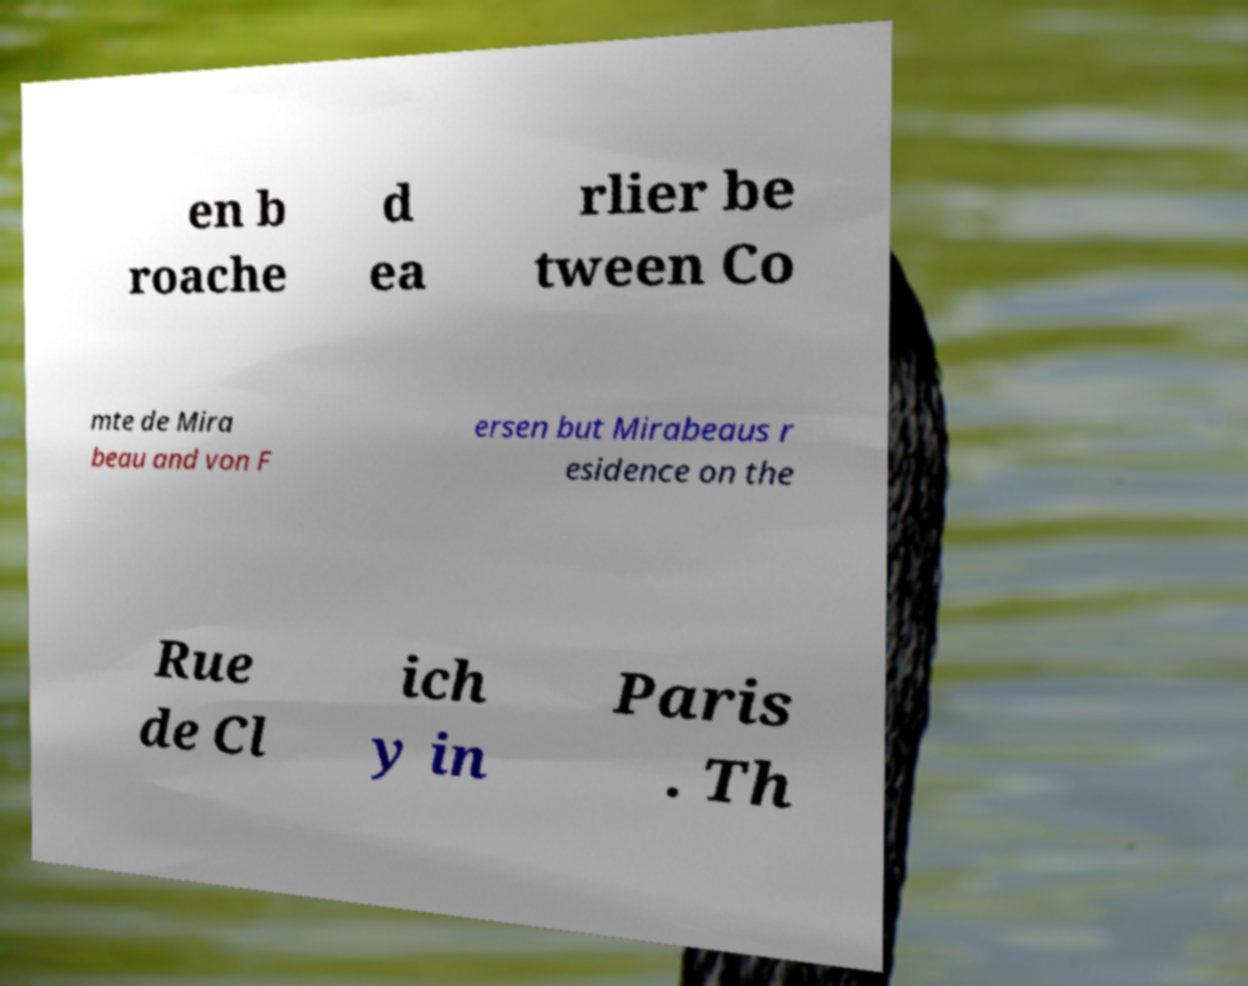Please identify and transcribe the text found in this image. en b roache d ea rlier be tween Co mte de Mira beau and von F ersen but Mirabeaus r esidence on the Rue de Cl ich y in Paris . Th 